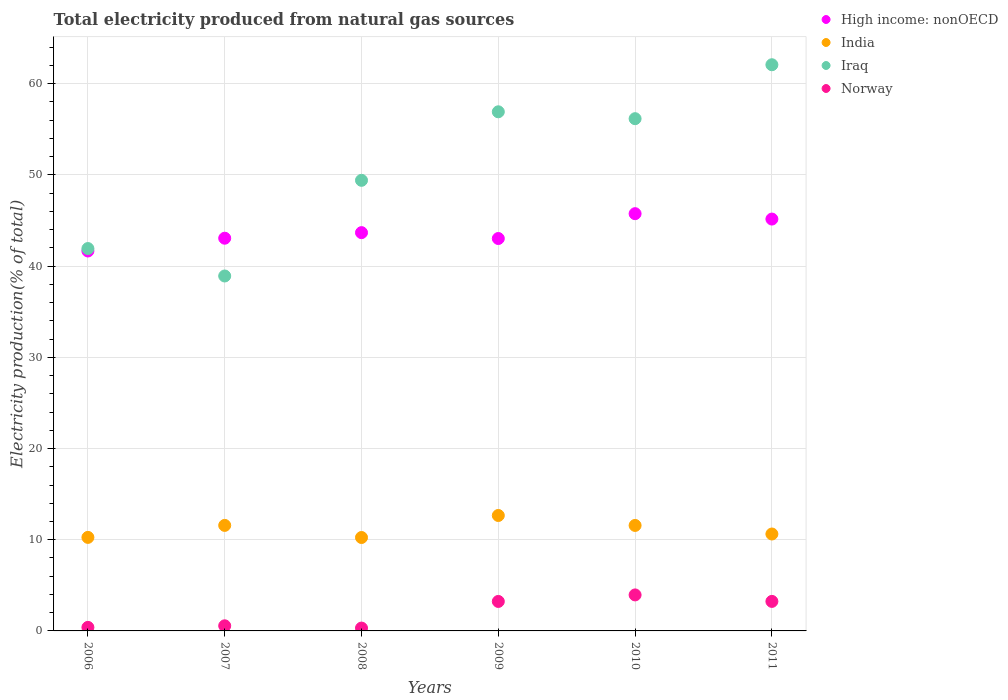What is the total electricity produced in Iraq in 2010?
Give a very brief answer. 56.17. Across all years, what is the maximum total electricity produced in Iraq?
Offer a terse response. 62.09. Across all years, what is the minimum total electricity produced in Norway?
Keep it short and to the point. 0.31. What is the total total electricity produced in Iraq in the graph?
Give a very brief answer. 305.44. What is the difference between the total electricity produced in Iraq in 2006 and that in 2008?
Ensure brevity in your answer.  -7.48. What is the difference between the total electricity produced in India in 2007 and the total electricity produced in Iraq in 2010?
Your answer should be compact. -44.6. What is the average total electricity produced in High income: nonOECD per year?
Ensure brevity in your answer.  43.72. In the year 2009, what is the difference between the total electricity produced in India and total electricity produced in High income: nonOECD?
Ensure brevity in your answer.  -30.37. In how many years, is the total electricity produced in High income: nonOECD greater than 62 %?
Your answer should be very brief. 0. What is the ratio of the total electricity produced in High income: nonOECD in 2006 to that in 2009?
Ensure brevity in your answer.  0.97. What is the difference between the highest and the second highest total electricity produced in High income: nonOECD?
Offer a very short reply. 0.59. What is the difference between the highest and the lowest total electricity produced in Norway?
Provide a succinct answer. 3.64. In how many years, is the total electricity produced in High income: nonOECD greater than the average total electricity produced in High income: nonOECD taken over all years?
Provide a succinct answer. 2. Is the sum of the total electricity produced in High income: nonOECD in 2006 and 2008 greater than the maximum total electricity produced in India across all years?
Give a very brief answer. Yes. Is it the case that in every year, the sum of the total electricity produced in Norway and total electricity produced in High income: nonOECD  is greater than the total electricity produced in India?
Keep it short and to the point. Yes. Is the total electricity produced in India strictly less than the total electricity produced in High income: nonOECD over the years?
Ensure brevity in your answer.  Yes. How many years are there in the graph?
Give a very brief answer. 6. What is the difference between two consecutive major ticks on the Y-axis?
Keep it short and to the point. 10. Does the graph contain grids?
Offer a very short reply. Yes. How many legend labels are there?
Offer a very short reply. 4. What is the title of the graph?
Keep it short and to the point. Total electricity produced from natural gas sources. Does "Swaziland" appear as one of the legend labels in the graph?
Provide a succinct answer. No. What is the label or title of the X-axis?
Make the answer very short. Years. What is the Electricity production(% of total) in High income: nonOECD in 2006?
Your response must be concise. 41.66. What is the Electricity production(% of total) of India in 2006?
Provide a succinct answer. 10.26. What is the Electricity production(% of total) of Iraq in 2006?
Give a very brief answer. 41.93. What is the Electricity production(% of total) of Norway in 2006?
Make the answer very short. 0.39. What is the Electricity production(% of total) in High income: nonOECD in 2007?
Your answer should be very brief. 43.06. What is the Electricity production(% of total) in India in 2007?
Your response must be concise. 11.57. What is the Electricity production(% of total) in Iraq in 2007?
Your answer should be compact. 38.92. What is the Electricity production(% of total) of Norway in 2007?
Ensure brevity in your answer.  0.56. What is the Electricity production(% of total) of High income: nonOECD in 2008?
Keep it short and to the point. 43.67. What is the Electricity production(% of total) of India in 2008?
Ensure brevity in your answer.  10.24. What is the Electricity production(% of total) of Iraq in 2008?
Give a very brief answer. 49.41. What is the Electricity production(% of total) of Norway in 2008?
Offer a very short reply. 0.31. What is the Electricity production(% of total) in High income: nonOECD in 2009?
Ensure brevity in your answer.  43.03. What is the Electricity production(% of total) in India in 2009?
Your answer should be compact. 12.66. What is the Electricity production(% of total) in Iraq in 2009?
Your answer should be very brief. 56.93. What is the Electricity production(% of total) of Norway in 2009?
Offer a very short reply. 3.23. What is the Electricity production(% of total) of High income: nonOECD in 2010?
Offer a very short reply. 45.75. What is the Electricity production(% of total) of India in 2010?
Make the answer very short. 11.57. What is the Electricity production(% of total) in Iraq in 2010?
Keep it short and to the point. 56.17. What is the Electricity production(% of total) of Norway in 2010?
Provide a short and direct response. 3.95. What is the Electricity production(% of total) in High income: nonOECD in 2011?
Give a very brief answer. 45.16. What is the Electricity production(% of total) in India in 2011?
Make the answer very short. 10.63. What is the Electricity production(% of total) of Iraq in 2011?
Give a very brief answer. 62.09. What is the Electricity production(% of total) in Norway in 2011?
Your answer should be very brief. 3.24. Across all years, what is the maximum Electricity production(% of total) in High income: nonOECD?
Provide a succinct answer. 45.75. Across all years, what is the maximum Electricity production(% of total) of India?
Your answer should be very brief. 12.66. Across all years, what is the maximum Electricity production(% of total) of Iraq?
Keep it short and to the point. 62.09. Across all years, what is the maximum Electricity production(% of total) of Norway?
Offer a terse response. 3.95. Across all years, what is the minimum Electricity production(% of total) of High income: nonOECD?
Keep it short and to the point. 41.66. Across all years, what is the minimum Electricity production(% of total) of India?
Provide a succinct answer. 10.24. Across all years, what is the minimum Electricity production(% of total) in Iraq?
Offer a very short reply. 38.92. Across all years, what is the minimum Electricity production(% of total) of Norway?
Ensure brevity in your answer.  0.31. What is the total Electricity production(% of total) in High income: nonOECD in the graph?
Offer a terse response. 262.34. What is the total Electricity production(% of total) of India in the graph?
Offer a terse response. 66.92. What is the total Electricity production(% of total) of Iraq in the graph?
Provide a short and direct response. 305.44. What is the total Electricity production(% of total) in Norway in the graph?
Your answer should be compact. 11.68. What is the difference between the Electricity production(% of total) of High income: nonOECD in 2006 and that in 2007?
Your answer should be compact. -1.4. What is the difference between the Electricity production(% of total) of India in 2006 and that in 2007?
Your response must be concise. -1.32. What is the difference between the Electricity production(% of total) in Iraq in 2006 and that in 2007?
Provide a succinct answer. 3.01. What is the difference between the Electricity production(% of total) in Norway in 2006 and that in 2007?
Provide a succinct answer. -0.17. What is the difference between the Electricity production(% of total) of High income: nonOECD in 2006 and that in 2008?
Provide a succinct answer. -2.01. What is the difference between the Electricity production(% of total) of India in 2006 and that in 2008?
Your response must be concise. 0.01. What is the difference between the Electricity production(% of total) in Iraq in 2006 and that in 2008?
Ensure brevity in your answer.  -7.48. What is the difference between the Electricity production(% of total) in Norway in 2006 and that in 2008?
Provide a short and direct response. 0.08. What is the difference between the Electricity production(% of total) in High income: nonOECD in 2006 and that in 2009?
Your answer should be very brief. -1.37. What is the difference between the Electricity production(% of total) of India in 2006 and that in 2009?
Your answer should be compact. -2.4. What is the difference between the Electricity production(% of total) of Iraq in 2006 and that in 2009?
Your answer should be very brief. -15. What is the difference between the Electricity production(% of total) in Norway in 2006 and that in 2009?
Provide a short and direct response. -2.84. What is the difference between the Electricity production(% of total) of High income: nonOECD in 2006 and that in 2010?
Offer a terse response. -4.09. What is the difference between the Electricity production(% of total) of India in 2006 and that in 2010?
Your answer should be compact. -1.31. What is the difference between the Electricity production(% of total) of Iraq in 2006 and that in 2010?
Give a very brief answer. -14.24. What is the difference between the Electricity production(% of total) of Norway in 2006 and that in 2010?
Provide a succinct answer. -3.56. What is the difference between the Electricity production(% of total) of High income: nonOECD in 2006 and that in 2011?
Make the answer very short. -3.5. What is the difference between the Electricity production(% of total) of India in 2006 and that in 2011?
Provide a succinct answer. -0.37. What is the difference between the Electricity production(% of total) of Iraq in 2006 and that in 2011?
Ensure brevity in your answer.  -20.16. What is the difference between the Electricity production(% of total) in Norway in 2006 and that in 2011?
Keep it short and to the point. -2.85. What is the difference between the Electricity production(% of total) of High income: nonOECD in 2007 and that in 2008?
Give a very brief answer. -0.61. What is the difference between the Electricity production(% of total) in India in 2007 and that in 2008?
Provide a short and direct response. 1.33. What is the difference between the Electricity production(% of total) of Iraq in 2007 and that in 2008?
Make the answer very short. -10.49. What is the difference between the Electricity production(% of total) of Norway in 2007 and that in 2008?
Your answer should be very brief. 0.25. What is the difference between the Electricity production(% of total) in High income: nonOECD in 2007 and that in 2009?
Your answer should be compact. 0.03. What is the difference between the Electricity production(% of total) of India in 2007 and that in 2009?
Provide a succinct answer. -1.09. What is the difference between the Electricity production(% of total) in Iraq in 2007 and that in 2009?
Your answer should be compact. -18. What is the difference between the Electricity production(% of total) of Norway in 2007 and that in 2009?
Your response must be concise. -2.67. What is the difference between the Electricity production(% of total) in High income: nonOECD in 2007 and that in 2010?
Make the answer very short. -2.69. What is the difference between the Electricity production(% of total) of India in 2007 and that in 2010?
Offer a very short reply. 0. What is the difference between the Electricity production(% of total) in Iraq in 2007 and that in 2010?
Your response must be concise. -17.25. What is the difference between the Electricity production(% of total) in Norway in 2007 and that in 2010?
Make the answer very short. -3.39. What is the difference between the Electricity production(% of total) in High income: nonOECD in 2007 and that in 2011?
Provide a short and direct response. -2.1. What is the difference between the Electricity production(% of total) of India in 2007 and that in 2011?
Keep it short and to the point. 0.94. What is the difference between the Electricity production(% of total) in Iraq in 2007 and that in 2011?
Offer a very short reply. -23.16. What is the difference between the Electricity production(% of total) of Norway in 2007 and that in 2011?
Offer a terse response. -2.68. What is the difference between the Electricity production(% of total) of High income: nonOECD in 2008 and that in 2009?
Your answer should be very brief. 0.64. What is the difference between the Electricity production(% of total) in India in 2008 and that in 2009?
Make the answer very short. -2.41. What is the difference between the Electricity production(% of total) of Iraq in 2008 and that in 2009?
Give a very brief answer. -7.51. What is the difference between the Electricity production(% of total) in Norway in 2008 and that in 2009?
Ensure brevity in your answer.  -2.92. What is the difference between the Electricity production(% of total) of High income: nonOECD in 2008 and that in 2010?
Give a very brief answer. -2.08. What is the difference between the Electricity production(% of total) in India in 2008 and that in 2010?
Offer a very short reply. -1.32. What is the difference between the Electricity production(% of total) of Iraq in 2008 and that in 2010?
Provide a short and direct response. -6.76. What is the difference between the Electricity production(% of total) in Norway in 2008 and that in 2010?
Make the answer very short. -3.64. What is the difference between the Electricity production(% of total) of High income: nonOECD in 2008 and that in 2011?
Make the answer very short. -1.49. What is the difference between the Electricity production(% of total) of India in 2008 and that in 2011?
Give a very brief answer. -0.38. What is the difference between the Electricity production(% of total) in Iraq in 2008 and that in 2011?
Ensure brevity in your answer.  -12.67. What is the difference between the Electricity production(% of total) of Norway in 2008 and that in 2011?
Your answer should be compact. -2.93. What is the difference between the Electricity production(% of total) in High income: nonOECD in 2009 and that in 2010?
Ensure brevity in your answer.  -2.72. What is the difference between the Electricity production(% of total) of India in 2009 and that in 2010?
Provide a succinct answer. 1.09. What is the difference between the Electricity production(% of total) in Iraq in 2009 and that in 2010?
Your answer should be very brief. 0.76. What is the difference between the Electricity production(% of total) in Norway in 2009 and that in 2010?
Keep it short and to the point. -0.72. What is the difference between the Electricity production(% of total) of High income: nonOECD in 2009 and that in 2011?
Provide a succinct answer. -2.13. What is the difference between the Electricity production(% of total) in India in 2009 and that in 2011?
Ensure brevity in your answer.  2.03. What is the difference between the Electricity production(% of total) in Iraq in 2009 and that in 2011?
Make the answer very short. -5.16. What is the difference between the Electricity production(% of total) of Norway in 2009 and that in 2011?
Keep it short and to the point. -0. What is the difference between the Electricity production(% of total) in High income: nonOECD in 2010 and that in 2011?
Keep it short and to the point. 0.59. What is the difference between the Electricity production(% of total) of India in 2010 and that in 2011?
Offer a terse response. 0.94. What is the difference between the Electricity production(% of total) in Iraq in 2010 and that in 2011?
Provide a short and direct response. -5.91. What is the difference between the Electricity production(% of total) of Norway in 2010 and that in 2011?
Give a very brief answer. 0.71. What is the difference between the Electricity production(% of total) in High income: nonOECD in 2006 and the Electricity production(% of total) in India in 2007?
Make the answer very short. 30.09. What is the difference between the Electricity production(% of total) of High income: nonOECD in 2006 and the Electricity production(% of total) of Iraq in 2007?
Provide a short and direct response. 2.74. What is the difference between the Electricity production(% of total) of High income: nonOECD in 2006 and the Electricity production(% of total) of Norway in 2007?
Offer a very short reply. 41.1. What is the difference between the Electricity production(% of total) of India in 2006 and the Electricity production(% of total) of Iraq in 2007?
Your response must be concise. -28.66. What is the difference between the Electricity production(% of total) of India in 2006 and the Electricity production(% of total) of Norway in 2007?
Your answer should be very brief. 9.7. What is the difference between the Electricity production(% of total) in Iraq in 2006 and the Electricity production(% of total) in Norway in 2007?
Give a very brief answer. 41.37. What is the difference between the Electricity production(% of total) of High income: nonOECD in 2006 and the Electricity production(% of total) of India in 2008?
Make the answer very short. 31.42. What is the difference between the Electricity production(% of total) in High income: nonOECD in 2006 and the Electricity production(% of total) in Iraq in 2008?
Give a very brief answer. -7.75. What is the difference between the Electricity production(% of total) of High income: nonOECD in 2006 and the Electricity production(% of total) of Norway in 2008?
Give a very brief answer. 41.35. What is the difference between the Electricity production(% of total) of India in 2006 and the Electricity production(% of total) of Iraq in 2008?
Ensure brevity in your answer.  -39.15. What is the difference between the Electricity production(% of total) of India in 2006 and the Electricity production(% of total) of Norway in 2008?
Offer a very short reply. 9.95. What is the difference between the Electricity production(% of total) of Iraq in 2006 and the Electricity production(% of total) of Norway in 2008?
Your answer should be very brief. 41.62. What is the difference between the Electricity production(% of total) in High income: nonOECD in 2006 and the Electricity production(% of total) in India in 2009?
Your answer should be compact. 29. What is the difference between the Electricity production(% of total) of High income: nonOECD in 2006 and the Electricity production(% of total) of Iraq in 2009?
Offer a very short reply. -15.26. What is the difference between the Electricity production(% of total) in High income: nonOECD in 2006 and the Electricity production(% of total) in Norway in 2009?
Your response must be concise. 38.43. What is the difference between the Electricity production(% of total) of India in 2006 and the Electricity production(% of total) of Iraq in 2009?
Offer a very short reply. -46.67. What is the difference between the Electricity production(% of total) in India in 2006 and the Electricity production(% of total) in Norway in 2009?
Your response must be concise. 7.02. What is the difference between the Electricity production(% of total) in Iraq in 2006 and the Electricity production(% of total) in Norway in 2009?
Provide a succinct answer. 38.7. What is the difference between the Electricity production(% of total) in High income: nonOECD in 2006 and the Electricity production(% of total) in India in 2010?
Offer a terse response. 30.09. What is the difference between the Electricity production(% of total) of High income: nonOECD in 2006 and the Electricity production(% of total) of Iraq in 2010?
Offer a terse response. -14.51. What is the difference between the Electricity production(% of total) in High income: nonOECD in 2006 and the Electricity production(% of total) in Norway in 2010?
Provide a short and direct response. 37.71. What is the difference between the Electricity production(% of total) of India in 2006 and the Electricity production(% of total) of Iraq in 2010?
Provide a short and direct response. -45.91. What is the difference between the Electricity production(% of total) of India in 2006 and the Electricity production(% of total) of Norway in 2010?
Provide a succinct answer. 6.31. What is the difference between the Electricity production(% of total) in Iraq in 2006 and the Electricity production(% of total) in Norway in 2010?
Provide a succinct answer. 37.98. What is the difference between the Electricity production(% of total) of High income: nonOECD in 2006 and the Electricity production(% of total) of India in 2011?
Your answer should be very brief. 31.03. What is the difference between the Electricity production(% of total) in High income: nonOECD in 2006 and the Electricity production(% of total) in Iraq in 2011?
Provide a succinct answer. -20.42. What is the difference between the Electricity production(% of total) in High income: nonOECD in 2006 and the Electricity production(% of total) in Norway in 2011?
Provide a short and direct response. 38.42. What is the difference between the Electricity production(% of total) of India in 2006 and the Electricity production(% of total) of Iraq in 2011?
Provide a succinct answer. -51.83. What is the difference between the Electricity production(% of total) of India in 2006 and the Electricity production(% of total) of Norway in 2011?
Provide a short and direct response. 7.02. What is the difference between the Electricity production(% of total) in Iraq in 2006 and the Electricity production(% of total) in Norway in 2011?
Ensure brevity in your answer.  38.69. What is the difference between the Electricity production(% of total) of High income: nonOECD in 2007 and the Electricity production(% of total) of India in 2008?
Provide a succinct answer. 32.82. What is the difference between the Electricity production(% of total) in High income: nonOECD in 2007 and the Electricity production(% of total) in Iraq in 2008?
Your response must be concise. -6.35. What is the difference between the Electricity production(% of total) in High income: nonOECD in 2007 and the Electricity production(% of total) in Norway in 2008?
Keep it short and to the point. 42.75. What is the difference between the Electricity production(% of total) of India in 2007 and the Electricity production(% of total) of Iraq in 2008?
Your response must be concise. -37.84. What is the difference between the Electricity production(% of total) in India in 2007 and the Electricity production(% of total) in Norway in 2008?
Ensure brevity in your answer.  11.26. What is the difference between the Electricity production(% of total) of Iraq in 2007 and the Electricity production(% of total) of Norway in 2008?
Your answer should be compact. 38.61. What is the difference between the Electricity production(% of total) of High income: nonOECD in 2007 and the Electricity production(% of total) of India in 2009?
Offer a very short reply. 30.41. What is the difference between the Electricity production(% of total) in High income: nonOECD in 2007 and the Electricity production(% of total) in Iraq in 2009?
Make the answer very short. -13.86. What is the difference between the Electricity production(% of total) in High income: nonOECD in 2007 and the Electricity production(% of total) in Norway in 2009?
Offer a terse response. 39.83. What is the difference between the Electricity production(% of total) in India in 2007 and the Electricity production(% of total) in Iraq in 2009?
Your answer should be very brief. -45.35. What is the difference between the Electricity production(% of total) in India in 2007 and the Electricity production(% of total) in Norway in 2009?
Keep it short and to the point. 8.34. What is the difference between the Electricity production(% of total) of Iraq in 2007 and the Electricity production(% of total) of Norway in 2009?
Your answer should be compact. 35.69. What is the difference between the Electricity production(% of total) in High income: nonOECD in 2007 and the Electricity production(% of total) in India in 2010?
Your answer should be compact. 31.5. What is the difference between the Electricity production(% of total) in High income: nonOECD in 2007 and the Electricity production(% of total) in Iraq in 2010?
Ensure brevity in your answer.  -13.11. What is the difference between the Electricity production(% of total) of High income: nonOECD in 2007 and the Electricity production(% of total) of Norway in 2010?
Your answer should be compact. 39.12. What is the difference between the Electricity production(% of total) in India in 2007 and the Electricity production(% of total) in Iraq in 2010?
Offer a terse response. -44.6. What is the difference between the Electricity production(% of total) in India in 2007 and the Electricity production(% of total) in Norway in 2010?
Offer a very short reply. 7.62. What is the difference between the Electricity production(% of total) in Iraq in 2007 and the Electricity production(% of total) in Norway in 2010?
Offer a very short reply. 34.97. What is the difference between the Electricity production(% of total) in High income: nonOECD in 2007 and the Electricity production(% of total) in India in 2011?
Provide a succinct answer. 32.44. What is the difference between the Electricity production(% of total) in High income: nonOECD in 2007 and the Electricity production(% of total) in Iraq in 2011?
Your answer should be compact. -19.02. What is the difference between the Electricity production(% of total) in High income: nonOECD in 2007 and the Electricity production(% of total) in Norway in 2011?
Offer a terse response. 39.83. What is the difference between the Electricity production(% of total) of India in 2007 and the Electricity production(% of total) of Iraq in 2011?
Provide a short and direct response. -50.51. What is the difference between the Electricity production(% of total) in India in 2007 and the Electricity production(% of total) in Norway in 2011?
Offer a terse response. 8.33. What is the difference between the Electricity production(% of total) in Iraq in 2007 and the Electricity production(% of total) in Norway in 2011?
Offer a very short reply. 35.68. What is the difference between the Electricity production(% of total) of High income: nonOECD in 2008 and the Electricity production(% of total) of India in 2009?
Your answer should be very brief. 31.02. What is the difference between the Electricity production(% of total) of High income: nonOECD in 2008 and the Electricity production(% of total) of Iraq in 2009?
Your answer should be very brief. -13.25. What is the difference between the Electricity production(% of total) of High income: nonOECD in 2008 and the Electricity production(% of total) of Norway in 2009?
Offer a very short reply. 40.44. What is the difference between the Electricity production(% of total) of India in 2008 and the Electricity production(% of total) of Iraq in 2009?
Offer a terse response. -46.68. What is the difference between the Electricity production(% of total) of India in 2008 and the Electricity production(% of total) of Norway in 2009?
Provide a short and direct response. 7.01. What is the difference between the Electricity production(% of total) in Iraq in 2008 and the Electricity production(% of total) in Norway in 2009?
Offer a terse response. 46.18. What is the difference between the Electricity production(% of total) in High income: nonOECD in 2008 and the Electricity production(% of total) in India in 2010?
Give a very brief answer. 32.11. What is the difference between the Electricity production(% of total) of High income: nonOECD in 2008 and the Electricity production(% of total) of Iraq in 2010?
Keep it short and to the point. -12.5. What is the difference between the Electricity production(% of total) of High income: nonOECD in 2008 and the Electricity production(% of total) of Norway in 2010?
Offer a terse response. 39.73. What is the difference between the Electricity production(% of total) of India in 2008 and the Electricity production(% of total) of Iraq in 2010?
Your answer should be very brief. -45.93. What is the difference between the Electricity production(% of total) of India in 2008 and the Electricity production(% of total) of Norway in 2010?
Keep it short and to the point. 6.3. What is the difference between the Electricity production(% of total) of Iraq in 2008 and the Electricity production(% of total) of Norway in 2010?
Offer a terse response. 45.46. What is the difference between the Electricity production(% of total) of High income: nonOECD in 2008 and the Electricity production(% of total) of India in 2011?
Ensure brevity in your answer.  33.05. What is the difference between the Electricity production(% of total) of High income: nonOECD in 2008 and the Electricity production(% of total) of Iraq in 2011?
Your answer should be compact. -18.41. What is the difference between the Electricity production(% of total) in High income: nonOECD in 2008 and the Electricity production(% of total) in Norway in 2011?
Make the answer very short. 40.44. What is the difference between the Electricity production(% of total) in India in 2008 and the Electricity production(% of total) in Iraq in 2011?
Provide a short and direct response. -51.84. What is the difference between the Electricity production(% of total) of India in 2008 and the Electricity production(% of total) of Norway in 2011?
Ensure brevity in your answer.  7.01. What is the difference between the Electricity production(% of total) of Iraq in 2008 and the Electricity production(% of total) of Norway in 2011?
Provide a succinct answer. 46.17. What is the difference between the Electricity production(% of total) of High income: nonOECD in 2009 and the Electricity production(% of total) of India in 2010?
Keep it short and to the point. 31.46. What is the difference between the Electricity production(% of total) of High income: nonOECD in 2009 and the Electricity production(% of total) of Iraq in 2010?
Your response must be concise. -13.14. What is the difference between the Electricity production(% of total) in High income: nonOECD in 2009 and the Electricity production(% of total) in Norway in 2010?
Keep it short and to the point. 39.08. What is the difference between the Electricity production(% of total) of India in 2009 and the Electricity production(% of total) of Iraq in 2010?
Make the answer very short. -43.51. What is the difference between the Electricity production(% of total) of India in 2009 and the Electricity production(% of total) of Norway in 2010?
Your response must be concise. 8.71. What is the difference between the Electricity production(% of total) of Iraq in 2009 and the Electricity production(% of total) of Norway in 2010?
Give a very brief answer. 52.98. What is the difference between the Electricity production(% of total) in High income: nonOECD in 2009 and the Electricity production(% of total) in India in 2011?
Offer a very short reply. 32.4. What is the difference between the Electricity production(% of total) in High income: nonOECD in 2009 and the Electricity production(% of total) in Iraq in 2011?
Offer a terse response. -19.06. What is the difference between the Electricity production(% of total) of High income: nonOECD in 2009 and the Electricity production(% of total) of Norway in 2011?
Your answer should be compact. 39.79. What is the difference between the Electricity production(% of total) in India in 2009 and the Electricity production(% of total) in Iraq in 2011?
Make the answer very short. -49.43. What is the difference between the Electricity production(% of total) in India in 2009 and the Electricity production(% of total) in Norway in 2011?
Provide a short and direct response. 9.42. What is the difference between the Electricity production(% of total) in Iraq in 2009 and the Electricity production(% of total) in Norway in 2011?
Offer a terse response. 53.69. What is the difference between the Electricity production(% of total) in High income: nonOECD in 2010 and the Electricity production(% of total) in India in 2011?
Give a very brief answer. 35.13. What is the difference between the Electricity production(% of total) of High income: nonOECD in 2010 and the Electricity production(% of total) of Iraq in 2011?
Give a very brief answer. -16.33. What is the difference between the Electricity production(% of total) in High income: nonOECD in 2010 and the Electricity production(% of total) in Norway in 2011?
Your response must be concise. 42.52. What is the difference between the Electricity production(% of total) in India in 2010 and the Electricity production(% of total) in Iraq in 2011?
Your answer should be compact. -50.52. What is the difference between the Electricity production(% of total) of India in 2010 and the Electricity production(% of total) of Norway in 2011?
Offer a terse response. 8.33. What is the difference between the Electricity production(% of total) in Iraq in 2010 and the Electricity production(% of total) in Norway in 2011?
Your answer should be very brief. 52.93. What is the average Electricity production(% of total) of High income: nonOECD per year?
Offer a very short reply. 43.72. What is the average Electricity production(% of total) in India per year?
Give a very brief answer. 11.15. What is the average Electricity production(% of total) of Iraq per year?
Make the answer very short. 50.91. What is the average Electricity production(% of total) in Norway per year?
Keep it short and to the point. 1.95. In the year 2006, what is the difference between the Electricity production(% of total) of High income: nonOECD and Electricity production(% of total) of India?
Your answer should be compact. 31.4. In the year 2006, what is the difference between the Electricity production(% of total) of High income: nonOECD and Electricity production(% of total) of Iraq?
Keep it short and to the point. -0.27. In the year 2006, what is the difference between the Electricity production(% of total) in High income: nonOECD and Electricity production(% of total) in Norway?
Your response must be concise. 41.27. In the year 2006, what is the difference between the Electricity production(% of total) of India and Electricity production(% of total) of Iraq?
Provide a short and direct response. -31.67. In the year 2006, what is the difference between the Electricity production(% of total) of India and Electricity production(% of total) of Norway?
Provide a succinct answer. 9.87. In the year 2006, what is the difference between the Electricity production(% of total) of Iraq and Electricity production(% of total) of Norway?
Offer a terse response. 41.54. In the year 2007, what is the difference between the Electricity production(% of total) of High income: nonOECD and Electricity production(% of total) of India?
Keep it short and to the point. 31.49. In the year 2007, what is the difference between the Electricity production(% of total) of High income: nonOECD and Electricity production(% of total) of Iraq?
Make the answer very short. 4.14. In the year 2007, what is the difference between the Electricity production(% of total) of High income: nonOECD and Electricity production(% of total) of Norway?
Provide a short and direct response. 42.5. In the year 2007, what is the difference between the Electricity production(% of total) of India and Electricity production(% of total) of Iraq?
Give a very brief answer. -27.35. In the year 2007, what is the difference between the Electricity production(% of total) of India and Electricity production(% of total) of Norway?
Offer a terse response. 11.01. In the year 2007, what is the difference between the Electricity production(% of total) of Iraq and Electricity production(% of total) of Norway?
Offer a very short reply. 38.36. In the year 2008, what is the difference between the Electricity production(% of total) of High income: nonOECD and Electricity production(% of total) of India?
Offer a very short reply. 33.43. In the year 2008, what is the difference between the Electricity production(% of total) of High income: nonOECD and Electricity production(% of total) of Iraq?
Your response must be concise. -5.74. In the year 2008, what is the difference between the Electricity production(% of total) in High income: nonOECD and Electricity production(% of total) in Norway?
Keep it short and to the point. 43.36. In the year 2008, what is the difference between the Electricity production(% of total) in India and Electricity production(% of total) in Iraq?
Ensure brevity in your answer.  -39.17. In the year 2008, what is the difference between the Electricity production(% of total) of India and Electricity production(% of total) of Norway?
Keep it short and to the point. 9.93. In the year 2008, what is the difference between the Electricity production(% of total) in Iraq and Electricity production(% of total) in Norway?
Your answer should be compact. 49.1. In the year 2009, what is the difference between the Electricity production(% of total) in High income: nonOECD and Electricity production(% of total) in India?
Your answer should be compact. 30.37. In the year 2009, what is the difference between the Electricity production(% of total) in High income: nonOECD and Electricity production(% of total) in Iraq?
Ensure brevity in your answer.  -13.9. In the year 2009, what is the difference between the Electricity production(% of total) of High income: nonOECD and Electricity production(% of total) of Norway?
Your answer should be compact. 39.8. In the year 2009, what is the difference between the Electricity production(% of total) in India and Electricity production(% of total) in Iraq?
Make the answer very short. -44.27. In the year 2009, what is the difference between the Electricity production(% of total) of India and Electricity production(% of total) of Norway?
Keep it short and to the point. 9.43. In the year 2009, what is the difference between the Electricity production(% of total) in Iraq and Electricity production(% of total) in Norway?
Your response must be concise. 53.69. In the year 2010, what is the difference between the Electricity production(% of total) in High income: nonOECD and Electricity production(% of total) in India?
Your answer should be very brief. 34.19. In the year 2010, what is the difference between the Electricity production(% of total) of High income: nonOECD and Electricity production(% of total) of Iraq?
Your answer should be very brief. -10.42. In the year 2010, what is the difference between the Electricity production(% of total) in High income: nonOECD and Electricity production(% of total) in Norway?
Give a very brief answer. 41.81. In the year 2010, what is the difference between the Electricity production(% of total) in India and Electricity production(% of total) in Iraq?
Ensure brevity in your answer.  -44.6. In the year 2010, what is the difference between the Electricity production(% of total) in India and Electricity production(% of total) in Norway?
Give a very brief answer. 7.62. In the year 2010, what is the difference between the Electricity production(% of total) of Iraq and Electricity production(% of total) of Norway?
Your answer should be compact. 52.22. In the year 2011, what is the difference between the Electricity production(% of total) of High income: nonOECD and Electricity production(% of total) of India?
Provide a short and direct response. 34.54. In the year 2011, what is the difference between the Electricity production(% of total) of High income: nonOECD and Electricity production(% of total) of Iraq?
Your response must be concise. -16.92. In the year 2011, what is the difference between the Electricity production(% of total) of High income: nonOECD and Electricity production(% of total) of Norway?
Offer a very short reply. 41.93. In the year 2011, what is the difference between the Electricity production(% of total) of India and Electricity production(% of total) of Iraq?
Your answer should be very brief. -51.46. In the year 2011, what is the difference between the Electricity production(% of total) of India and Electricity production(% of total) of Norway?
Provide a succinct answer. 7.39. In the year 2011, what is the difference between the Electricity production(% of total) in Iraq and Electricity production(% of total) in Norway?
Keep it short and to the point. 58.85. What is the ratio of the Electricity production(% of total) of High income: nonOECD in 2006 to that in 2007?
Keep it short and to the point. 0.97. What is the ratio of the Electricity production(% of total) of India in 2006 to that in 2007?
Offer a very short reply. 0.89. What is the ratio of the Electricity production(% of total) in Iraq in 2006 to that in 2007?
Give a very brief answer. 1.08. What is the ratio of the Electricity production(% of total) of Norway in 2006 to that in 2007?
Ensure brevity in your answer.  0.69. What is the ratio of the Electricity production(% of total) in High income: nonOECD in 2006 to that in 2008?
Offer a terse response. 0.95. What is the ratio of the Electricity production(% of total) of India in 2006 to that in 2008?
Ensure brevity in your answer.  1. What is the ratio of the Electricity production(% of total) in Iraq in 2006 to that in 2008?
Your response must be concise. 0.85. What is the ratio of the Electricity production(% of total) in Norway in 2006 to that in 2008?
Your response must be concise. 1.25. What is the ratio of the Electricity production(% of total) in High income: nonOECD in 2006 to that in 2009?
Your response must be concise. 0.97. What is the ratio of the Electricity production(% of total) in India in 2006 to that in 2009?
Ensure brevity in your answer.  0.81. What is the ratio of the Electricity production(% of total) of Iraq in 2006 to that in 2009?
Your answer should be very brief. 0.74. What is the ratio of the Electricity production(% of total) in Norway in 2006 to that in 2009?
Offer a very short reply. 0.12. What is the ratio of the Electricity production(% of total) of High income: nonOECD in 2006 to that in 2010?
Provide a succinct answer. 0.91. What is the ratio of the Electricity production(% of total) in India in 2006 to that in 2010?
Your answer should be very brief. 0.89. What is the ratio of the Electricity production(% of total) in Iraq in 2006 to that in 2010?
Keep it short and to the point. 0.75. What is the ratio of the Electricity production(% of total) in Norway in 2006 to that in 2010?
Keep it short and to the point. 0.1. What is the ratio of the Electricity production(% of total) of High income: nonOECD in 2006 to that in 2011?
Offer a very short reply. 0.92. What is the ratio of the Electricity production(% of total) of India in 2006 to that in 2011?
Provide a short and direct response. 0.97. What is the ratio of the Electricity production(% of total) of Iraq in 2006 to that in 2011?
Ensure brevity in your answer.  0.68. What is the ratio of the Electricity production(% of total) in Norway in 2006 to that in 2011?
Offer a terse response. 0.12. What is the ratio of the Electricity production(% of total) in India in 2007 to that in 2008?
Your answer should be very brief. 1.13. What is the ratio of the Electricity production(% of total) of Iraq in 2007 to that in 2008?
Provide a succinct answer. 0.79. What is the ratio of the Electricity production(% of total) in Norway in 2007 to that in 2008?
Your answer should be very brief. 1.8. What is the ratio of the Electricity production(% of total) in High income: nonOECD in 2007 to that in 2009?
Give a very brief answer. 1. What is the ratio of the Electricity production(% of total) in India in 2007 to that in 2009?
Your answer should be compact. 0.91. What is the ratio of the Electricity production(% of total) of Iraq in 2007 to that in 2009?
Keep it short and to the point. 0.68. What is the ratio of the Electricity production(% of total) of Norway in 2007 to that in 2009?
Make the answer very short. 0.17. What is the ratio of the Electricity production(% of total) in High income: nonOECD in 2007 to that in 2010?
Offer a terse response. 0.94. What is the ratio of the Electricity production(% of total) of India in 2007 to that in 2010?
Provide a short and direct response. 1. What is the ratio of the Electricity production(% of total) of Iraq in 2007 to that in 2010?
Keep it short and to the point. 0.69. What is the ratio of the Electricity production(% of total) in Norway in 2007 to that in 2010?
Provide a succinct answer. 0.14. What is the ratio of the Electricity production(% of total) of High income: nonOECD in 2007 to that in 2011?
Offer a very short reply. 0.95. What is the ratio of the Electricity production(% of total) in India in 2007 to that in 2011?
Ensure brevity in your answer.  1.09. What is the ratio of the Electricity production(% of total) in Iraq in 2007 to that in 2011?
Offer a very short reply. 0.63. What is the ratio of the Electricity production(% of total) in Norway in 2007 to that in 2011?
Provide a short and direct response. 0.17. What is the ratio of the Electricity production(% of total) in India in 2008 to that in 2009?
Make the answer very short. 0.81. What is the ratio of the Electricity production(% of total) of Iraq in 2008 to that in 2009?
Your response must be concise. 0.87. What is the ratio of the Electricity production(% of total) of Norway in 2008 to that in 2009?
Provide a short and direct response. 0.1. What is the ratio of the Electricity production(% of total) of High income: nonOECD in 2008 to that in 2010?
Provide a succinct answer. 0.95. What is the ratio of the Electricity production(% of total) of India in 2008 to that in 2010?
Your answer should be very brief. 0.89. What is the ratio of the Electricity production(% of total) of Iraq in 2008 to that in 2010?
Ensure brevity in your answer.  0.88. What is the ratio of the Electricity production(% of total) in Norway in 2008 to that in 2010?
Provide a succinct answer. 0.08. What is the ratio of the Electricity production(% of total) of High income: nonOECD in 2008 to that in 2011?
Your response must be concise. 0.97. What is the ratio of the Electricity production(% of total) of India in 2008 to that in 2011?
Provide a short and direct response. 0.96. What is the ratio of the Electricity production(% of total) in Iraq in 2008 to that in 2011?
Keep it short and to the point. 0.8. What is the ratio of the Electricity production(% of total) in Norway in 2008 to that in 2011?
Provide a succinct answer. 0.1. What is the ratio of the Electricity production(% of total) of High income: nonOECD in 2009 to that in 2010?
Keep it short and to the point. 0.94. What is the ratio of the Electricity production(% of total) in India in 2009 to that in 2010?
Your answer should be very brief. 1.09. What is the ratio of the Electricity production(% of total) in Iraq in 2009 to that in 2010?
Your response must be concise. 1.01. What is the ratio of the Electricity production(% of total) of Norway in 2009 to that in 2010?
Provide a succinct answer. 0.82. What is the ratio of the Electricity production(% of total) of High income: nonOECD in 2009 to that in 2011?
Provide a succinct answer. 0.95. What is the ratio of the Electricity production(% of total) in India in 2009 to that in 2011?
Give a very brief answer. 1.19. What is the ratio of the Electricity production(% of total) of Iraq in 2009 to that in 2011?
Provide a succinct answer. 0.92. What is the ratio of the Electricity production(% of total) in High income: nonOECD in 2010 to that in 2011?
Ensure brevity in your answer.  1.01. What is the ratio of the Electricity production(% of total) in India in 2010 to that in 2011?
Offer a very short reply. 1.09. What is the ratio of the Electricity production(% of total) in Iraq in 2010 to that in 2011?
Provide a short and direct response. 0.9. What is the ratio of the Electricity production(% of total) of Norway in 2010 to that in 2011?
Ensure brevity in your answer.  1.22. What is the difference between the highest and the second highest Electricity production(% of total) in High income: nonOECD?
Your answer should be very brief. 0.59. What is the difference between the highest and the second highest Electricity production(% of total) of India?
Keep it short and to the point. 1.09. What is the difference between the highest and the second highest Electricity production(% of total) of Iraq?
Your answer should be very brief. 5.16. What is the difference between the highest and the second highest Electricity production(% of total) in Norway?
Your answer should be very brief. 0.71. What is the difference between the highest and the lowest Electricity production(% of total) in High income: nonOECD?
Offer a very short reply. 4.09. What is the difference between the highest and the lowest Electricity production(% of total) in India?
Your answer should be compact. 2.41. What is the difference between the highest and the lowest Electricity production(% of total) of Iraq?
Provide a succinct answer. 23.16. What is the difference between the highest and the lowest Electricity production(% of total) of Norway?
Make the answer very short. 3.64. 